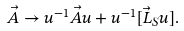Convert formula to latex. <formula><loc_0><loc_0><loc_500><loc_500>\vec { A } \rightarrow u ^ { - 1 } \vec { A } u + u ^ { - 1 } [ \vec { L } _ { S } u ] .</formula> 